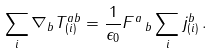Convert formula to latex. <formula><loc_0><loc_0><loc_500><loc_500>\sum _ { i } \nabla _ { b } T _ { ( i ) } ^ { a b } = \frac { 1 } { \epsilon _ { 0 } } F ^ { a } \, _ { b } \sum _ { i } j _ { ( i ) } ^ { b } \, .</formula> 